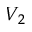<formula> <loc_0><loc_0><loc_500><loc_500>V _ { 2 }</formula> 